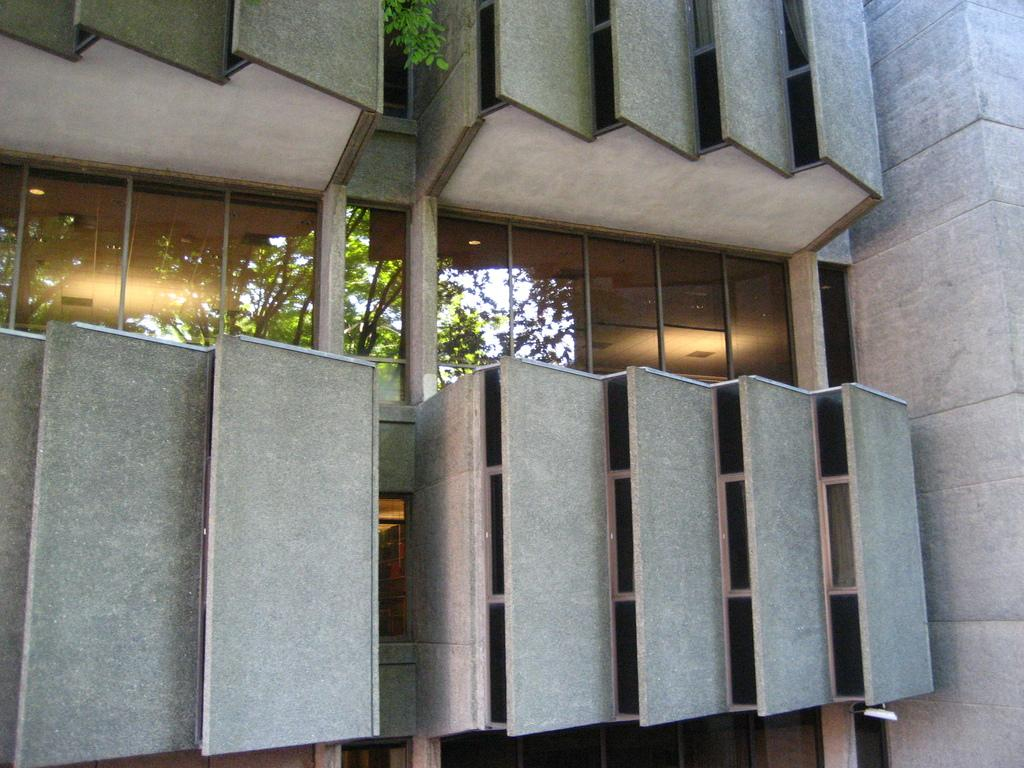What is the main subject of the image? The main subject of the image is a building wall. What is attached to the building wall? There is a glass on the wall. What is depicted on the glass? The glass has an image of trees on it. Can you describe the surrounding area in the image? There is another building wall visible beside the glass. How many feet are visible in the image? There are no feet visible in the image; it primarily features a building wall and a glass with an image of trees. 